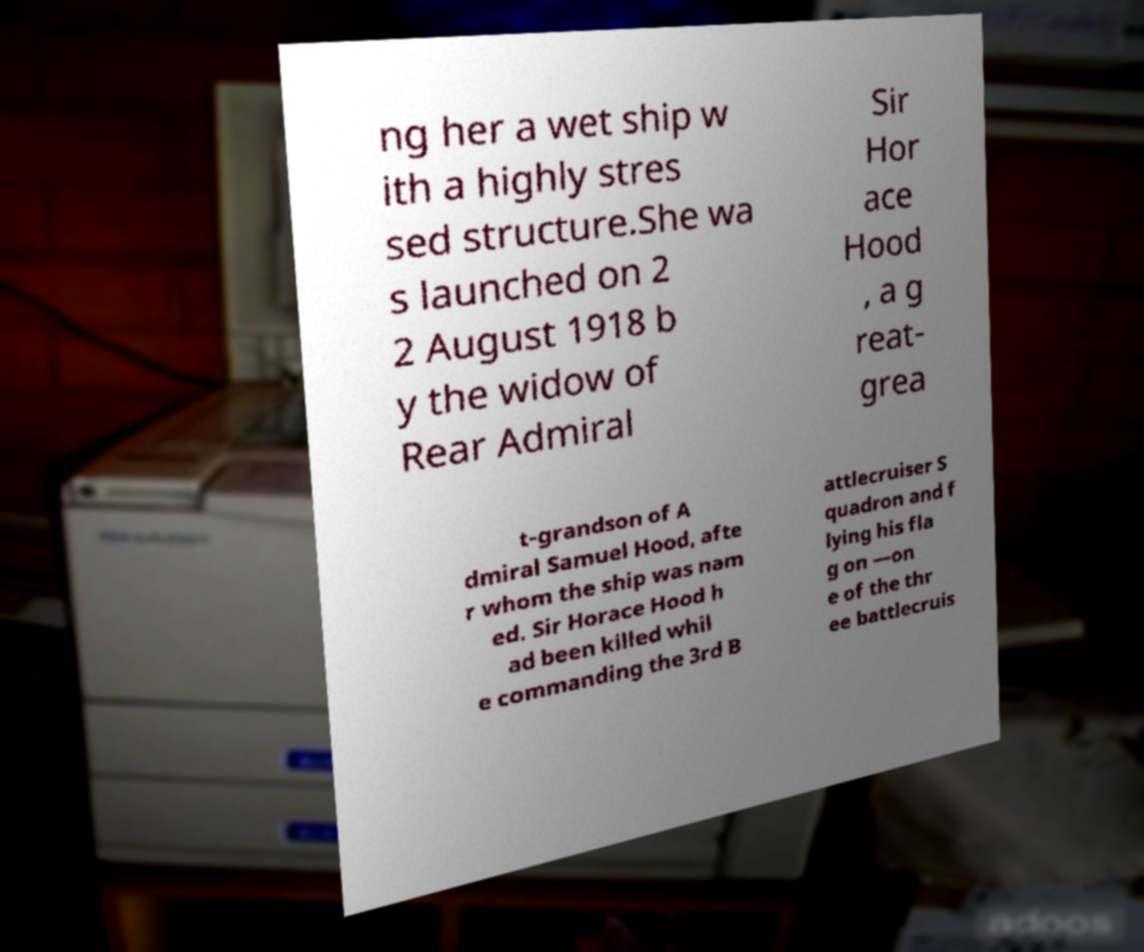For documentation purposes, I need the text within this image transcribed. Could you provide that? ng her a wet ship w ith a highly stres sed structure.She wa s launched on 2 2 August 1918 b y the widow of Rear Admiral Sir Hor ace Hood , a g reat- grea t-grandson of A dmiral Samuel Hood, afte r whom the ship was nam ed. Sir Horace Hood h ad been killed whil e commanding the 3rd B attlecruiser S quadron and f lying his fla g on —on e of the thr ee battlecruis 